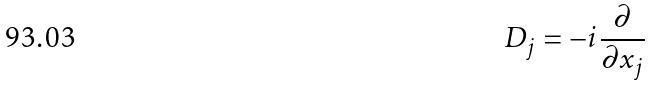<formula> <loc_0><loc_0><loc_500><loc_500>D _ { j } = - i \frac { \partial } { \partial x _ { j } }</formula> 